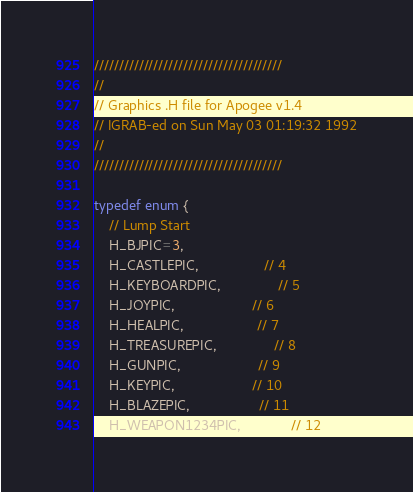<code> <loc_0><loc_0><loc_500><loc_500><_C_>//////////////////////////////////////
//
// Graphics .H file for Apogee v1.4
// IGRAB-ed on Sun May 03 01:19:32 1992
//
//////////////////////////////////////

typedef enum {
    // Lump Start
    H_BJPIC=3,
    H_CASTLEPIC,                 // 4
    H_KEYBOARDPIC,               // 5
    H_JOYPIC,                    // 6
    H_HEALPIC,                   // 7
    H_TREASUREPIC,               // 8
    H_GUNPIC,                    // 9
    H_KEYPIC,                    // 10
    H_BLAZEPIC,                  // 11
    H_WEAPON1234PIC,             // 12</code> 